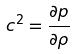Convert formula to latex. <formula><loc_0><loc_0><loc_500><loc_500>c ^ { 2 } = \frac { \partial p } { \partial \rho }</formula> 